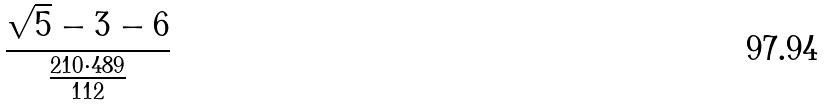<formula> <loc_0><loc_0><loc_500><loc_500>\frac { \sqrt { 5 } - 3 - 6 } { \frac { 2 1 0 \cdot 4 8 9 } { 1 1 2 } }</formula> 